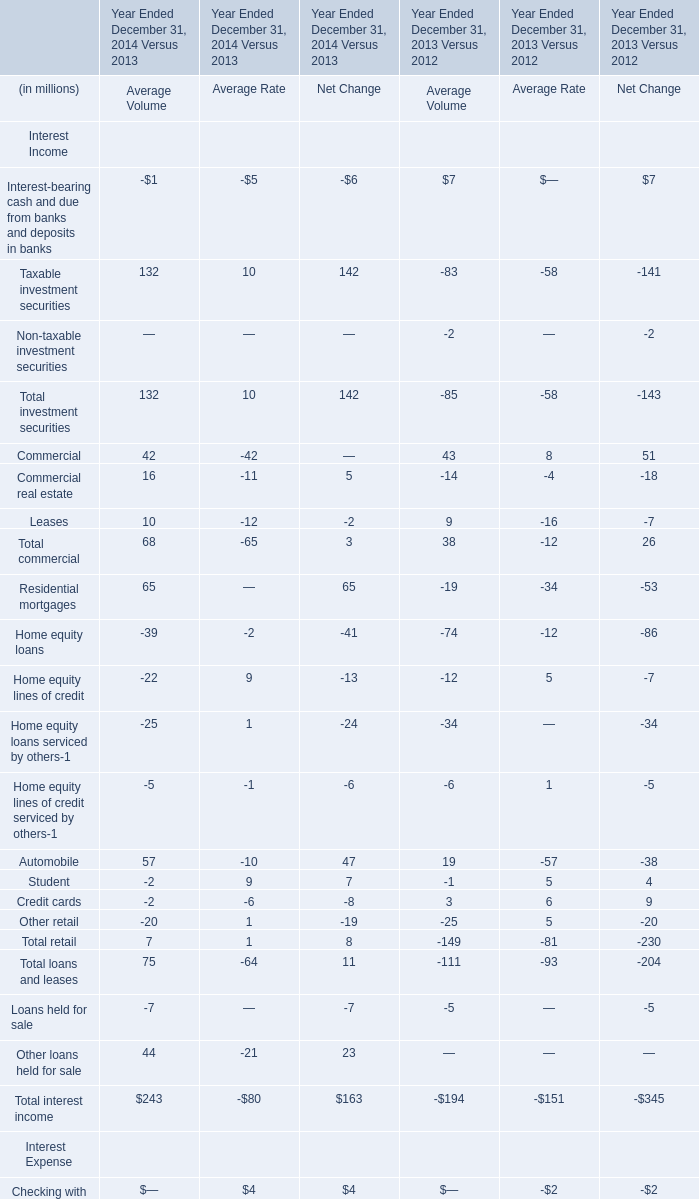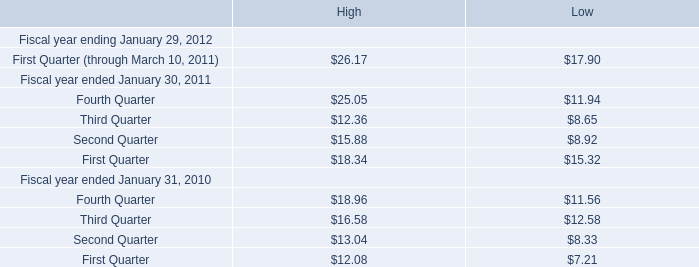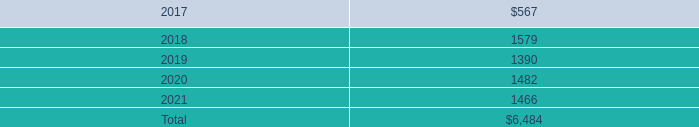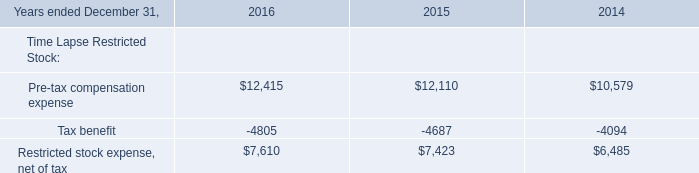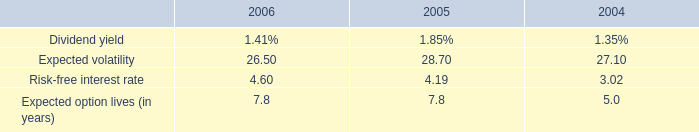what is the growth rate in the risk-free interest rate from 2004 to 2005? 
Computations: ((4.19 - 3.02) / 3.02)
Answer: 0.38742. 